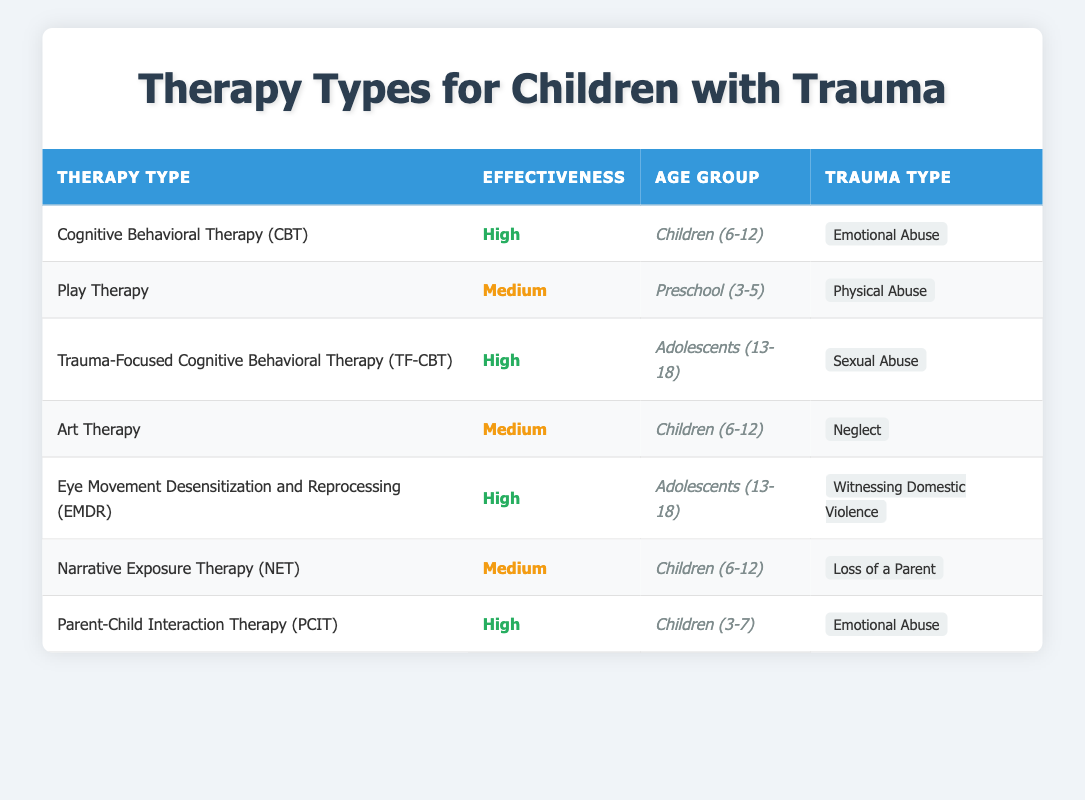What type of therapy is noted for high effectiveness in children aged 6-12 for emotional abuse? In the table, we look for the row where the age group is "Children (6-12)" and the trauma type is "Emotional Abuse." The relevant therapy listed there is "Cognitive Behavioral Therapy (CBT)."
Answer: Cognitive Behavioral Therapy (CBT) How many types of therapy are listed for adolescents (ages 13-18) and what are they? The table has two rows for the age group "Adolescents (13-18)." They are "Trauma-Focused Cognitive Behavioral Therapy (TF-CBT)" and "Eye Movement Desensitization and Reprocessing (EMDR)."
Answer: Two: Trauma-Focused Cognitive Behavioral Therapy (TF-CBT), Eye Movement Desensitization and Reprocessing (EMDR) Is Art Therapy rated as high effectiveness for any age group? Checking the table shows that "Art Therapy" is listed as having a medium effectiveness rating. Therefore, it is not rated as high.
Answer: No Which age group has the highest count of therapies with high effectiveness ratings? First, we look at the effectiveness column for ratings marked as high. The age groups "Children (3-7)" and "Adolescents (13-18)" each have multiple therapies listed. Counting the high ratings: "Children (3-7)" has one (PCIT) and "Adolescents (13-18)" has two (TF-CBT, EMDR). Therefore, "Adolescents (13-18)" has the highest count of high effectiveness.
Answer: Adolescents (13-18) What is the average effectiveness of therapy for children aged 6-12 that is rated as medium? The therapies applicable to children aged 6-12 that have medium effectiveness are "Art Therapy" and "Narrative Exposure Therapy (NET)." Since both are rated as medium, the average can be determined as (1+1)/2 = 1, which still maintains the medium rating across both therapies without needing a numerical scoring system.
Answer: Medium Is there any therapy type used for loss of a parent, and if so, what is its effectiveness? Looking at the trauma type "Loss of a Parent," we see that "Narrative Exposure Therapy (NET)" is listed with a medium effectiveness rating.
Answer: Yes, Narrative Exposure Therapy (NET), medium effectiveness Which therapy has the highest effectiveness rating for witnessing domestic violence among adolescents? We check the trauma type for "Witnessing Domestic Violence" in the age group of adolescents. The therapy mentioned for this situation is "Eye Movement Desensitization and Reprocessing (EMDR)" which is rated high.
Answer: Eye Movement Desensitization and Reprocessing (EMDR) How does the effectiveness of Parent-Child Interaction Therapy (PCIT) compare to Play Therapy? PCIT is rated high effectiveness while Play Therapy is rated medium. When comparing scores, high is superior to medium in effectiveness.
Answer: PCIT is higher than Play Therapy 